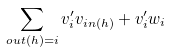<formula> <loc_0><loc_0><loc_500><loc_500>\sum _ { o u t ( h ) = i } v ^ { \prime } _ { i } v _ { i n ( h ) } + v ^ { \prime } _ { i } w _ { i }</formula> 